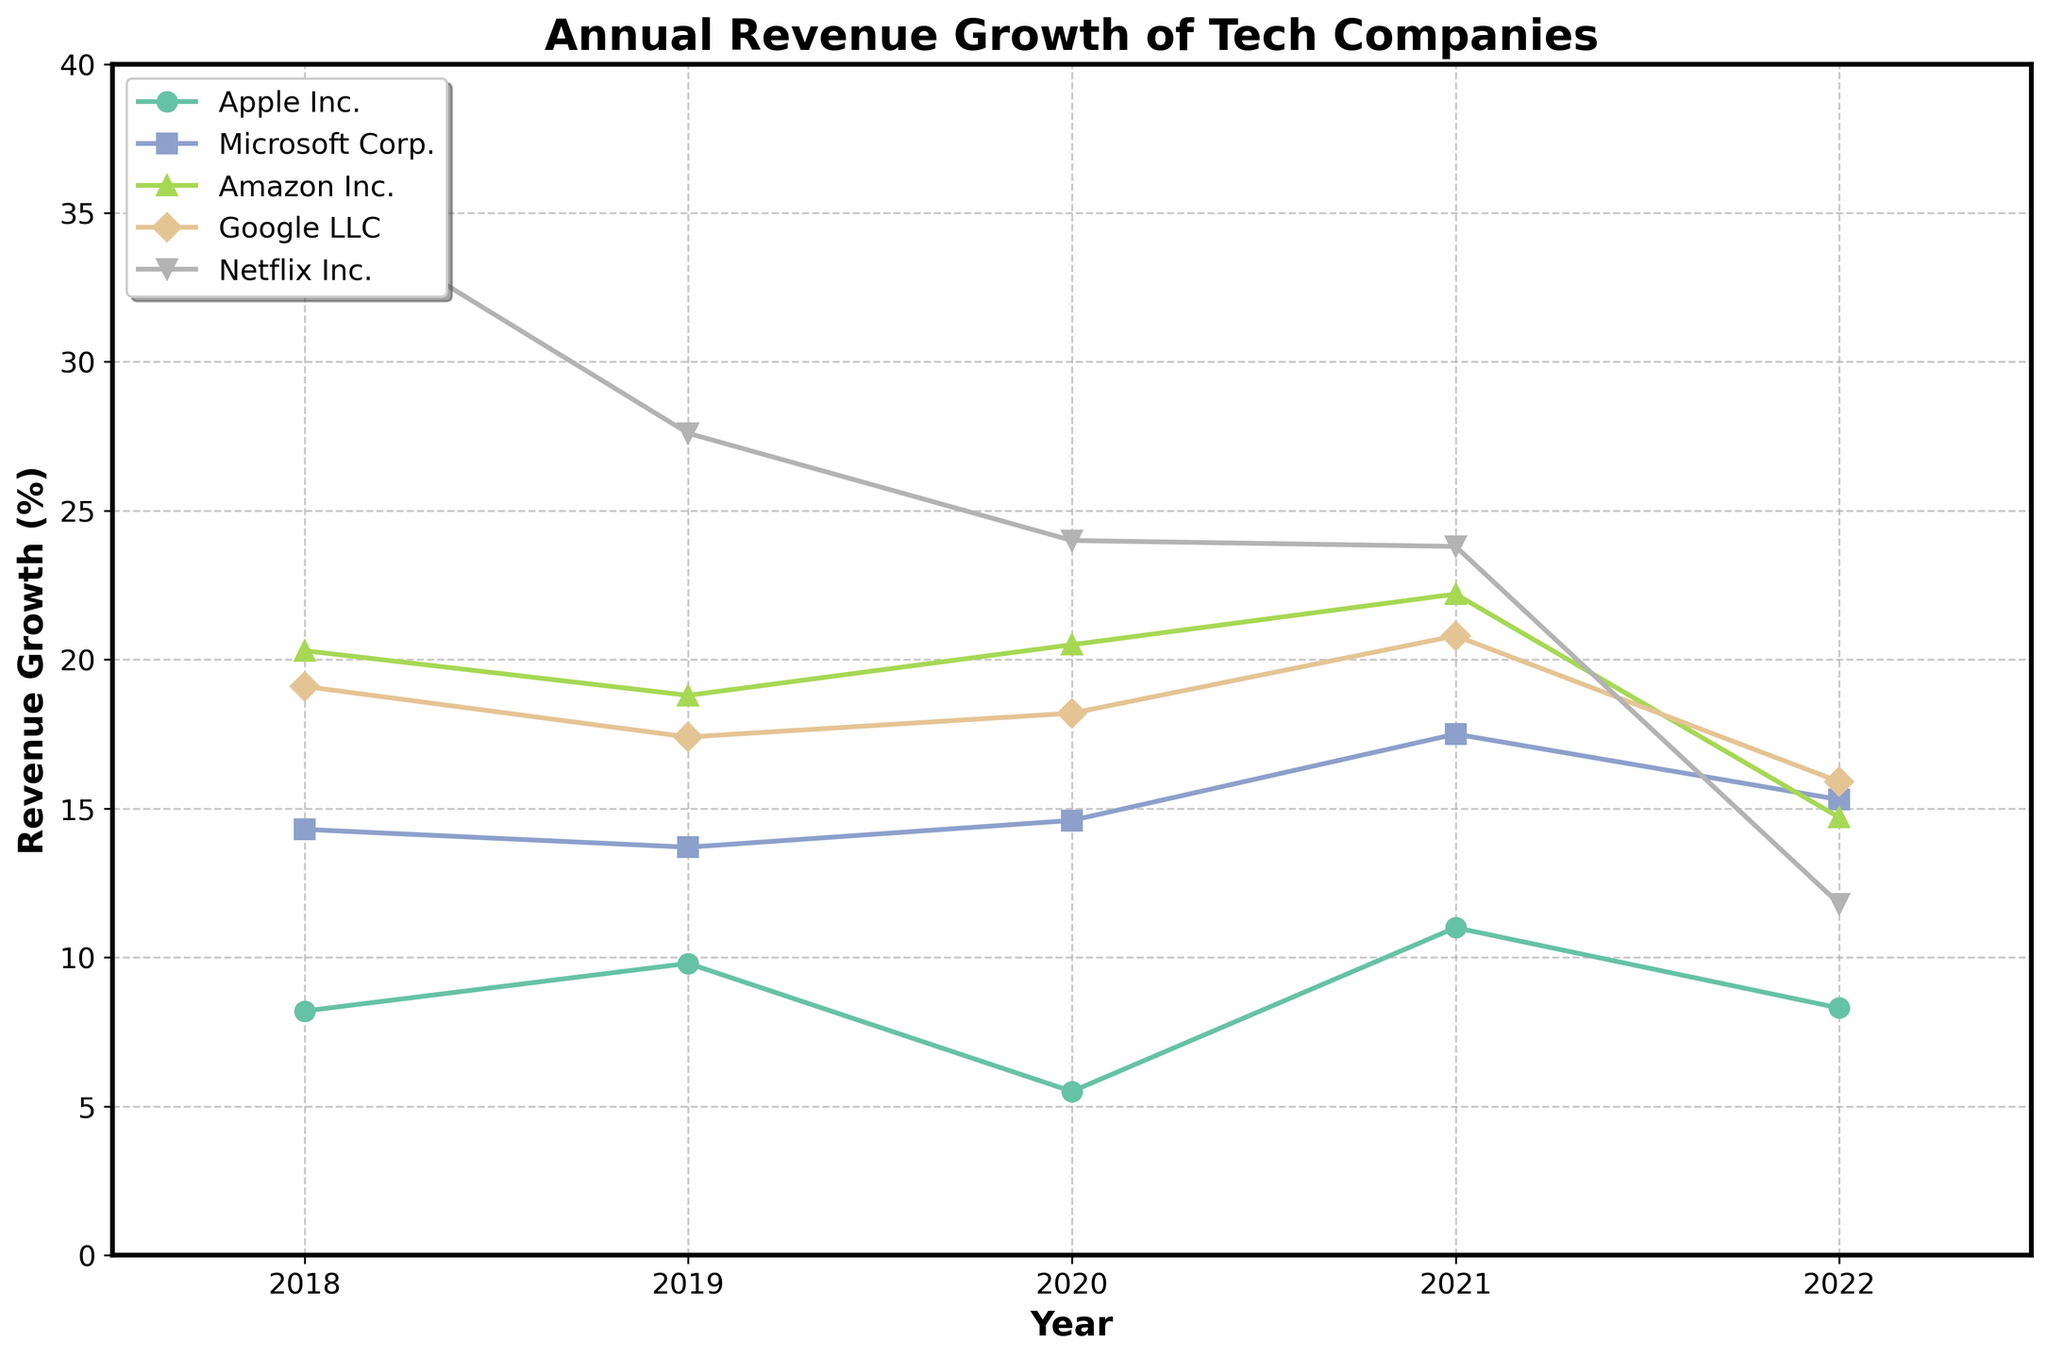What is the title of the plot? The title is located at the top of the plot, and typically indicates the main subject or focus of the plot.
Answer: Annual Revenue Growth of Tech Companies Which company had the highest revenue growth in 2022? Look at the data points marked at the year 2022 and identify the highest value among them. Netflix Inc. has the highest point in 2022.
Answer: Netflix Inc How many companies are shown in the plot? Count the distinct lines in the plot, each representing a different company. There are five lines each marked with different colors and symbols.
Answer: Five Between Apple Inc. and Microsoft Corp., which company showed higher revenue growth in 2021? Trace the lines for Apple Inc. and Microsoft Corp. to the year 2021 and compare the height of the data points. Microsoft Corp.'s point is higher than Apple Inc.'s.
Answer: Microsoft Corp What is the range of the y-axis? Check the lowest and highest values on the y-axis which indicate the range.
Answer: 0 to 40 Which company experienced the largest drop in revenue growth from 2021 to 2022? Observe the slope between data points from 2021 to 2022 for each company and identify the steepest decrease. Netflix Inc. shows the largest decline.
Answer: Netflix Inc What was the average revenue growth for Amazon Inc. from 2018 to 2022? Sum the annual revenue growth percentages for Amazon Inc. from 2018, 2019, 2020, 2021, and 2022 and divide by the number of years. Calculation: (20.30 + 18.80 + 20.50 + 22.20 + 14.70) / 5 = 96.50 / 5.
Answer: 19.30% Which sector had the most stable revenue growth between 2018 and 2022? Compare the variations in the lines representing each sector. The line with the least fluctuations indicates the most stable growth. Microsoft Corp., representing the Software sector, shows the least fluctuation.
Answer: Software How does the revenue growth trend for Google LLC compare to Amazon Inc.? Observe both lines for Google LLC and Amazon Inc. from 2018 to 2022. Both companies experienced fluctuations but Amazon Inc. had a larger decline in 2022 compared to Google LLC.
Answer: Amazon Inc. had larger fluctuations 